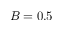Convert formula to latex. <formula><loc_0><loc_0><loc_500><loc_500>B = 0 . 5</formula> 